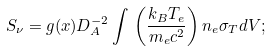Convert formula to latex. <formula><loc_0><loc_0><loc_500><loc_500>S _ { \nu } = g ( x ) D _ { A } ^ { - 2 } \int \, \left ( \frac { k _ { B } T _ { e } } { m _ { e } c ^ { 2 } } \right ) n _ { e } \sigma _ { T } d V ;</formula> 